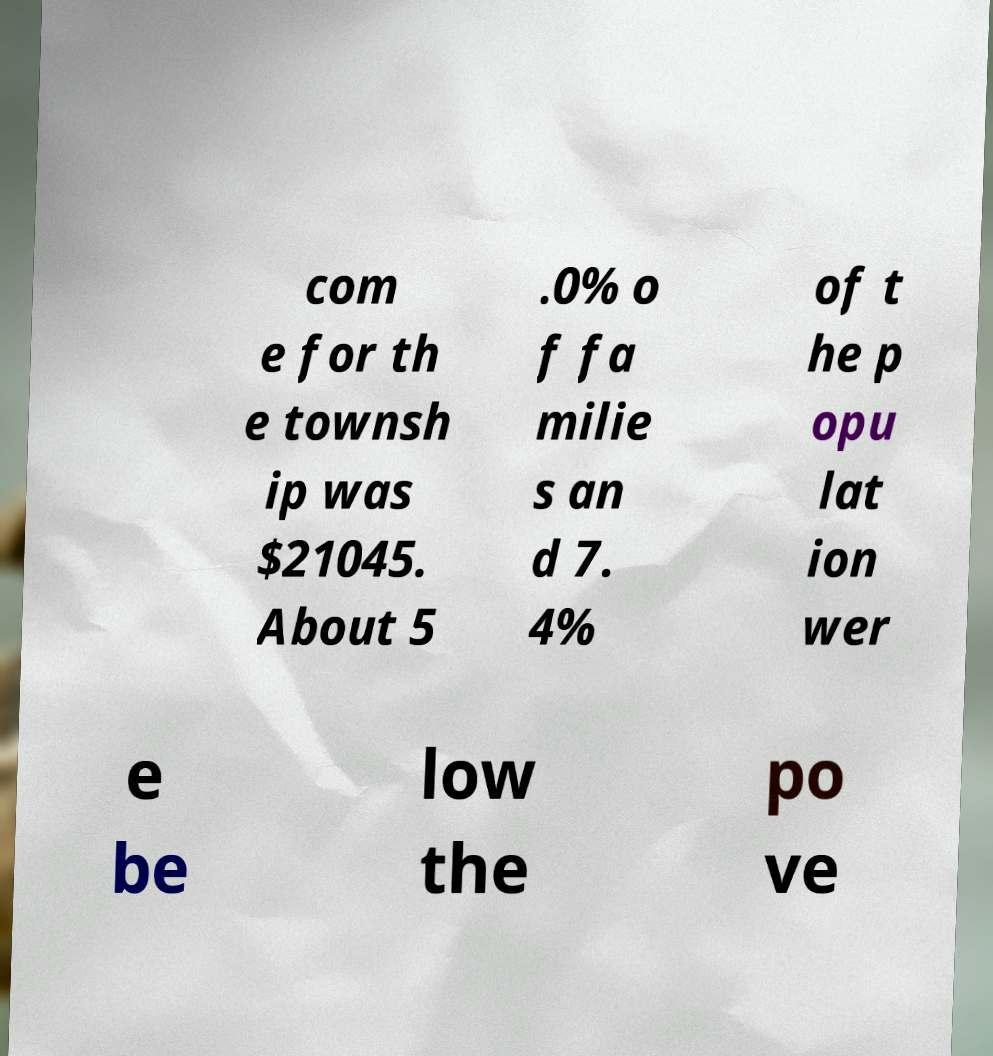There's text embedded in this image that I need extracted. Can you transcribe it verbatim? com e for th e townsh ip was $21045. About 5 .0% o f fa milie s an d 7. 4% of t he p opu lat ion wer e be low the po ve 